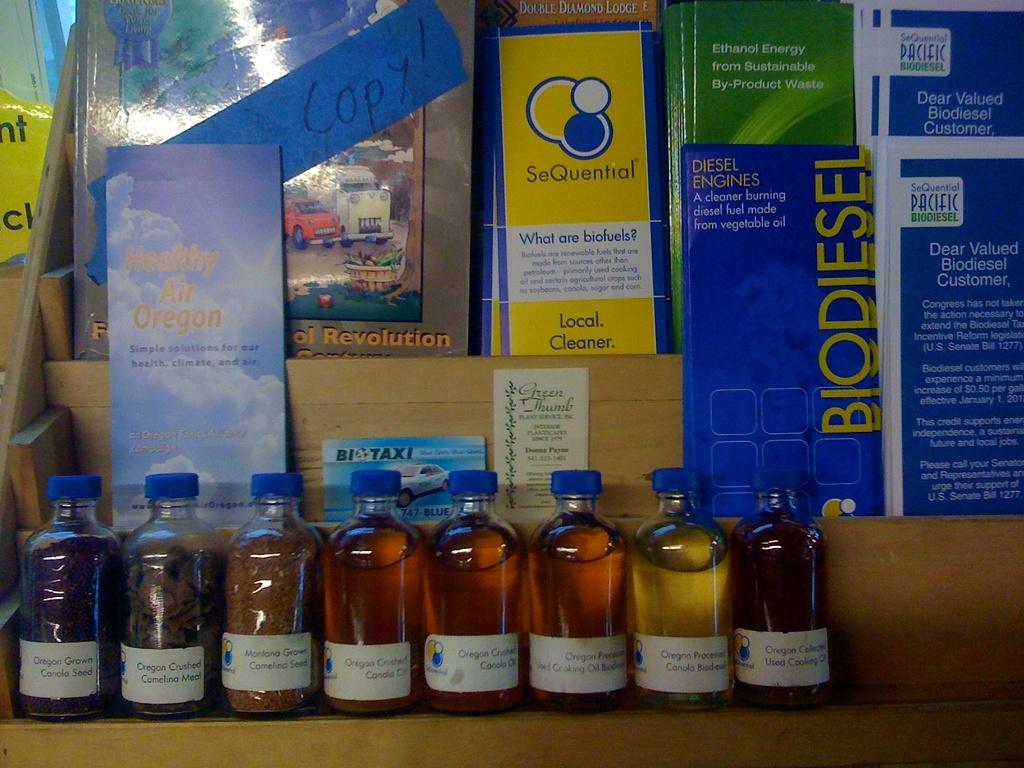<image>
Relay a brief, clear account of the picture shown. several small bottles sit on front of a display for Biofuels 